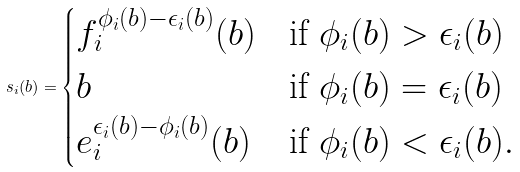<formula> <loc_0><loc_0><loc_500><loc_500>s _ { i } ( b ) = \begin{cases} f _ { i } ^ { \phi _ { i } ( b ) - \epsilon _ { i } ( b ) } ( b ) & \text {if $\phi_{i}(b)>\epsilon_{i}(b)$} \\ b & \text {if $\phi_{i}(b)=\epsilon_{i}(b)$} \\ e _ { i } ^ { \epsilon _ { i } ( b ) - \phi _ { i } ( b ) } ( b ) & \text {if $\phi_{i}(b)<\epsilon_{i}(b)$} . \end{cases}</formula> 